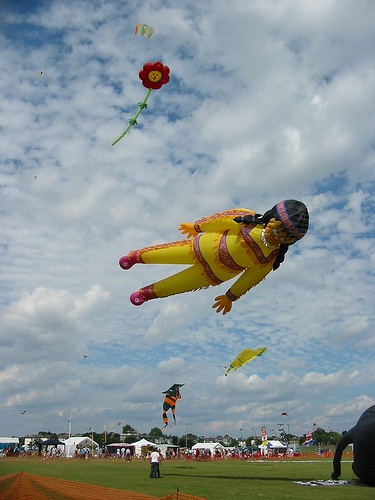Describe the objects in this image and their specific colors. I can see kite in blue, olive, black, and maroon tones, people in blue, olive, black, gray, and maroon tones, kite in blue, maroon, darkgray, olive, and black tones, kite in blue, black, darkgray, brown, and maroon tones, and kite in blue, olive, and darkgray tones in this image. 